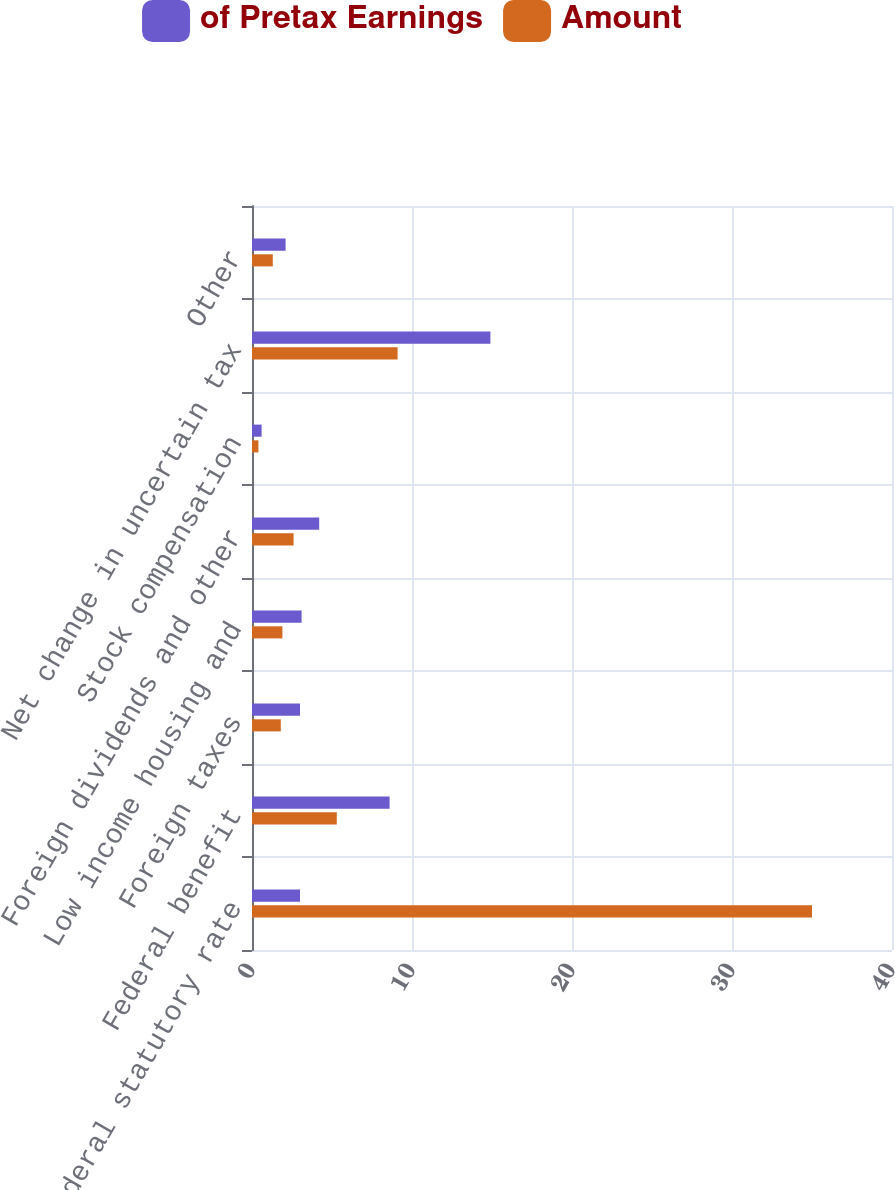Convert chart. <chart><loc_0><loc_0><loc_500><loc_500><stacked_bar_chart><ecel><fcel>Federal statutory rate<fcel>Federal benefit<fcel>Foreign taxes<fcel>Low income housing and<fcel>Foreign dividends and other<fcel>Stock compensation<fcel>Net change in uncertain tax<fcel>Other<nl><fcel>of Pretax Earnings<fcel>3<fcel>8.6<fcel>3<fcel>3.1<fcel>4.2<fcel>0.6<fcel>14.9<fcel>2.1<nl><fcel>Amount<fcel>35<fcel>5.3<fcel>1.8<fcel>1.9<fcel>2.6<fcel>0.4<fcel>9.1<fcel>1.3<nl></chart> 